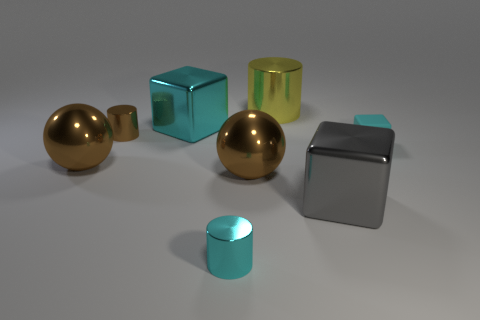How might the different textures of the objects affect their appearance? The various textures of the objects significantly influence their appearance. The metallic surfaces reflect light and create highlights, while the matte surfaces, like the cyan cube, absorb light, displaying more uniform color and less pronounced reflections. 